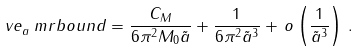<formula> <loc_0><loc_0><loc_500><loc_500>\ v e _ { a } ^ { \ } m r { b o u n d } = \frac { C _ { M } } { 6 \pi ^ { 2 } M _ { 0 } \tilde { a } } + \frac { 1 } { 6 \pi ^ { 2 } \tilde { a } ^ { 3 } } + \, o \left ( \frac { 1 } { \tilde { a } ^ { 3 } } \right ) \, .</formula> 